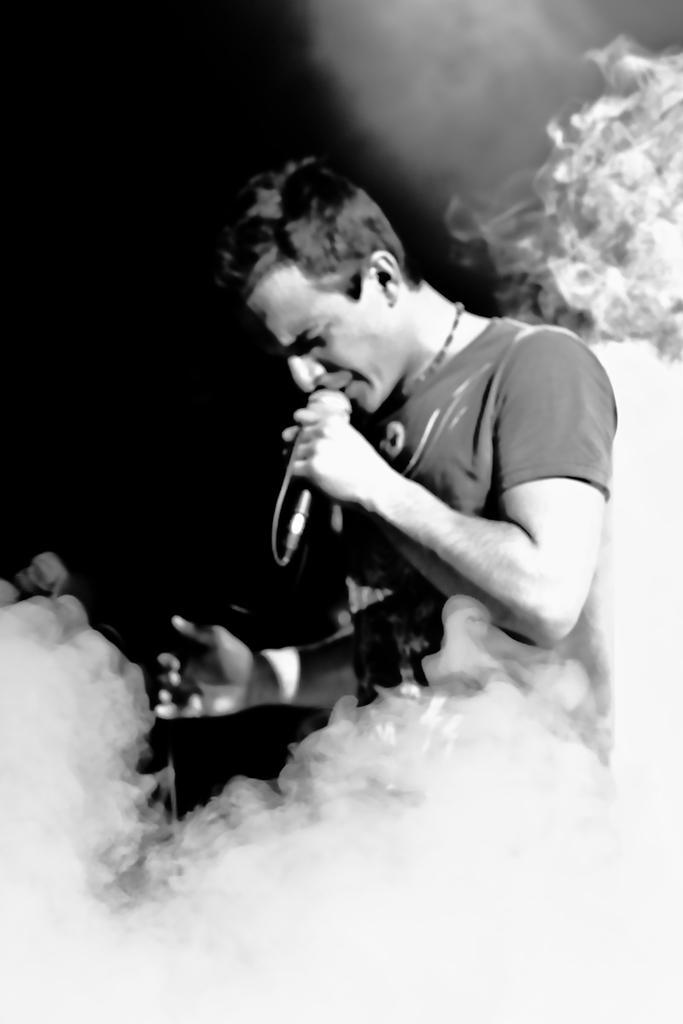Please provide a concise description of this image. In this image a man is singing. he is holding one mic. He is wearing a t shirt. 